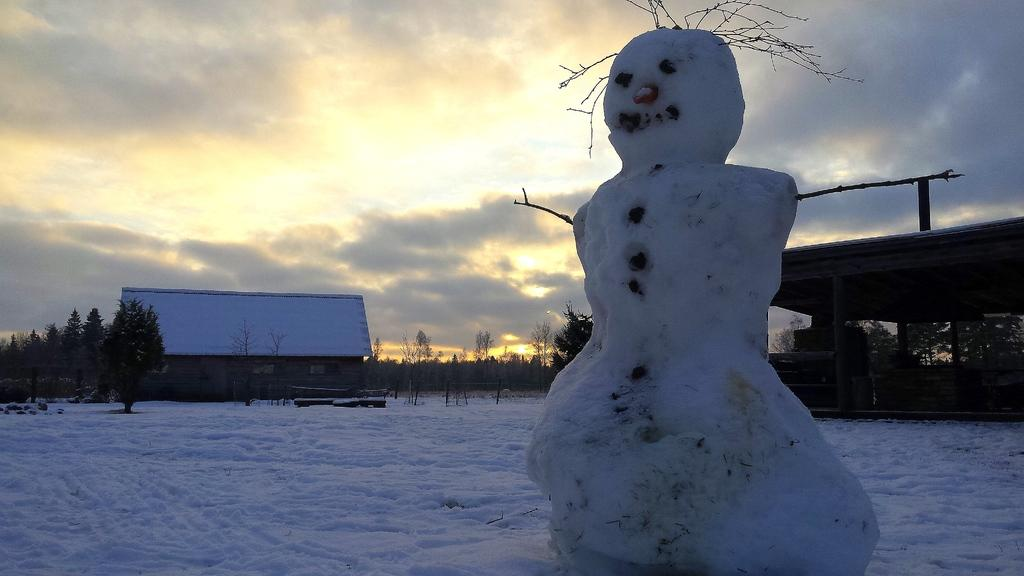What is the main subject of the picture? There is a snowman in the picture. What is the condition of the road in the picture? The road is covered with snow. What type of seating is present in the picture? There are wooden benches in the picture. What type of vegetation is present in the picture? There are trees in the picture. What type of building is present in the picture? There is a house in the picture. What is visible in the background of the picture? The sky with clouds is visible in the background. What type of birthday celebration is taking place in the picture? There is no indication of a birthday celebration in the picture. What is the relationship between the moon and the snowman in the picture? The moon is not present in the picture; it is the sky with clouds that is visible in the background. 